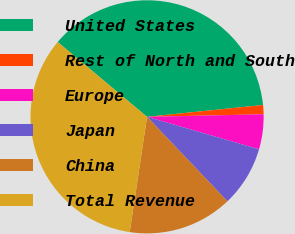<chart> <loc_0><loc_0><loc_500><loc_500><pie_chart><fcel>United States<fcel>Rest of North and South<fcel>Europe<fcel>Japan<fcel>China<fcel>Total Revenue<nl><fcel>37.29%<fcel>1.27%<fcel>4.84%<fcel>8.41%<fcel>14.48%<fcel>33.72%<nl></chart> 